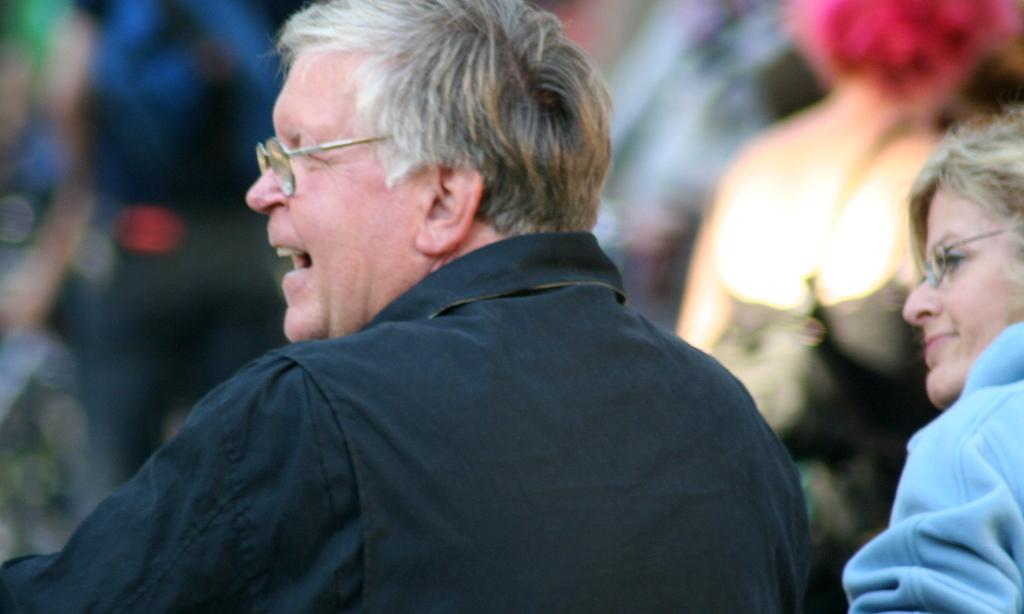What is the gender of the person in the image? There is a man in the image. What is the man wearing? The man is wearing a black shirt. What direction is the man facing? The man is facing backwards. Can you describe the woman in the image? The woman is wearing a blue dress. How does the man help the woman open the door in the image? There is no door present in the image, and the man is not shown helping the woman with anything. 